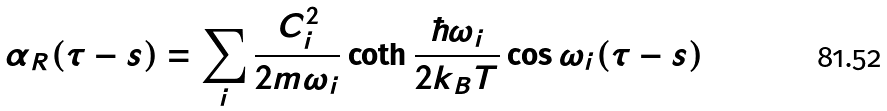<formula> <loc_0><loc_0><loc_500><loc_500>\alpha _ { R } ( \tau - s ) = \sum _ { i } \frac { C _ { i } ^ { 2 } } { 2 m \omega _ { i } } \coth \frac { \hbar { \omega } _ { i } } { 2 k _ { B } T } \cos \omega _ { i } ( \tau - s )</formula> 